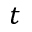Convert formula to latex. <formula><loc_0><loc_0><loc_500><loc_500>t</formula> 